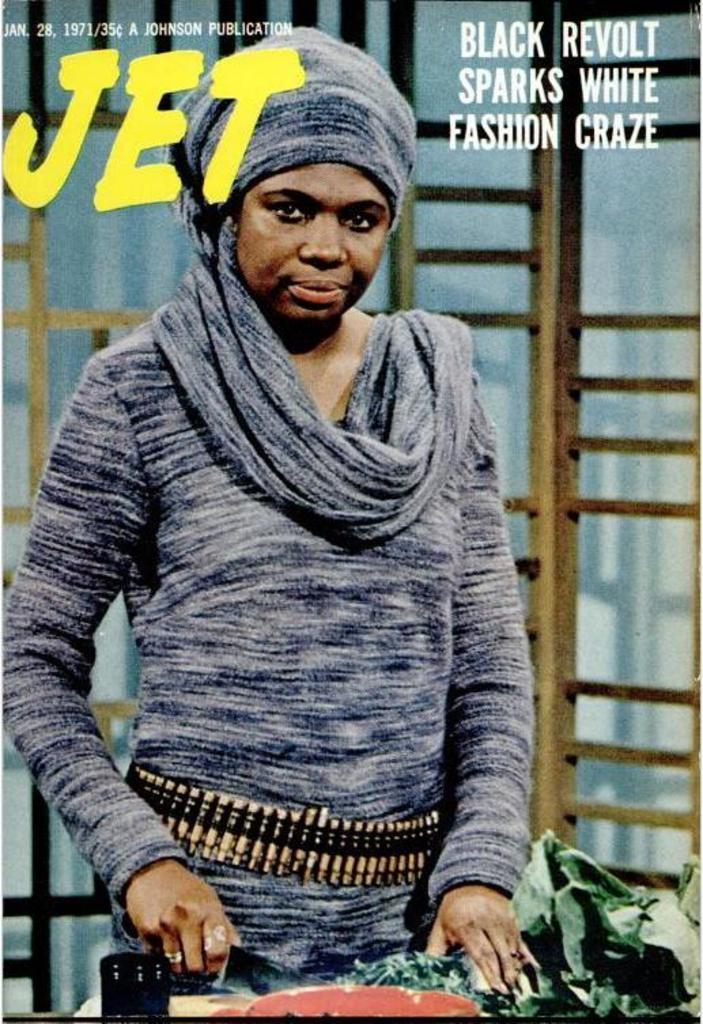Please provide a concise description of this image. In this picture we can see a poster, on this poster we can see a person and text. 